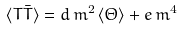<formula> <loc_0><loc_0><loc_500><loc_500>\langle T \bar { T } \rangle = d \, m ^ { 2 } \, \langle \Theta \rangle + e \, m ^ { 4 }</formula> 